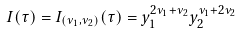<formula> <loc_0><loc_0><loc_500><loc_500>I ( \tau ) = I _ { ( \nu _ { 1 } , \nu _ { 2 } ) } ( \tau ) = y _ { 1 } ^ { 2 \nu _ { 1 } + \nu _ { 2 } } y _ { 2 } ^ { \nu _ { 1 } + 2 \nu _ { 2 } }</formula> 